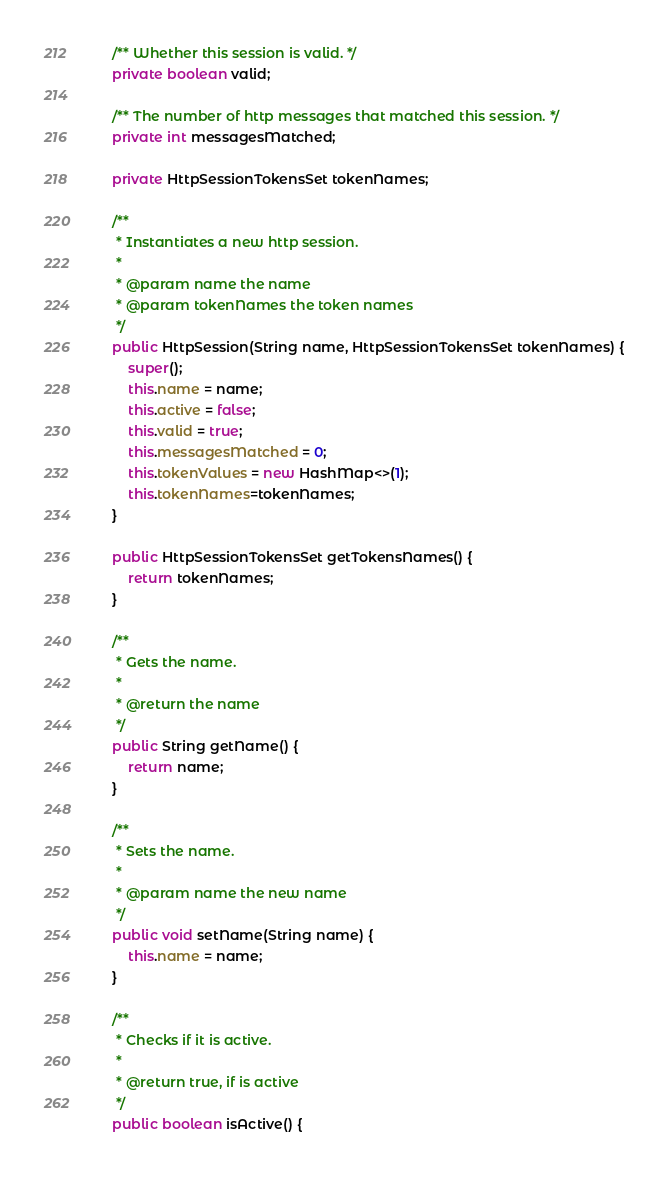Convert code to text. <code><loc_0><loc_0><loc_500><loc_500><_Java_>
	/** Whether this session is valid. */
	private boolean valid;

	/** The number of http messages that matched this session. */
	private int messagesMatched;
	
	private HttpSessionTokensSet tokenNames;

	/**
	 * Instantiates a new http session.
	 *
	 * @param name the name
	 * @param tokenNames the token names
	 */
	public HttpSession(String name, HttpSessionTokensSet tokenNames) {
		super();
		this.name = name;
		this.active = false;
		this.valid = true;
		this.messagesMatched = 0;
		this.tokenValues = new HashMap<>(1);
		this.tokenNames=tokenNames;
	}

	public HttpSessionTokensSet getTokensNames() {
		return tokenNames;
	}

	/**
	 * Gets the name.
	 * 
	 * @return the name
	 */
	public String getName() {
		return name;
	}

	/**
	 * Sets the name.
	 * 
	 * @param name the new name
	 */
	public void setName(String name) {
		this.name = name;
	}

	/**
	 * Checks if it is active.
	 * 
	 * @return true, if is active
	 */
	public boolean isActive() {</code> 